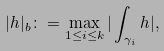<formula> <loc_0><loc_0><loc_500><loc_500>| h | _ { b } \colon = \max _ { 1 \leq i \leq k } | \int _ { \gamma _ { i } } h | ,</formula> 